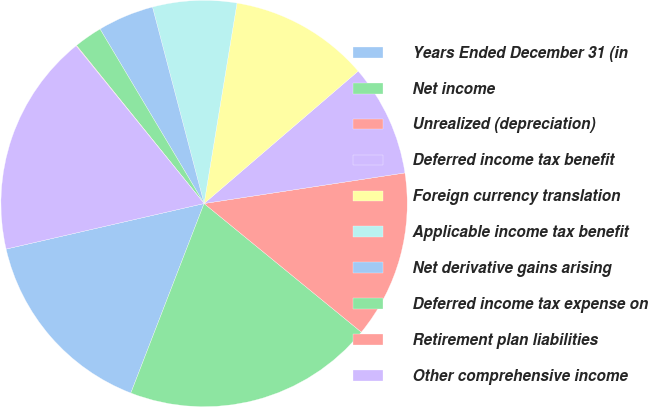Convert chart. <chart><loc_0><loc_0><loc_500><loc_500><pie_chart><fcel>Years Ended December 31 (in<fcel>Net income<fcel>Unrealized (depreciation)<fcel>Deferred income tax benefit<fcel>Foreign currency translation<fcel>Applicable income tax benefit<fcel>Net derivative gains arising<fcel>Deferred income tax expense on<fcel>Retirement plan liabilities<fcel>Other comprehensive income<nl><fcel>15.53%<fcel>19.96%<fcel>13.32%<fcel>8.89%<fcel>11.11%<fcel>6.68%<fcel>4.47%<fcel>2.25%<fcel>0.04%<fcel>17.75%<nl></chart> 